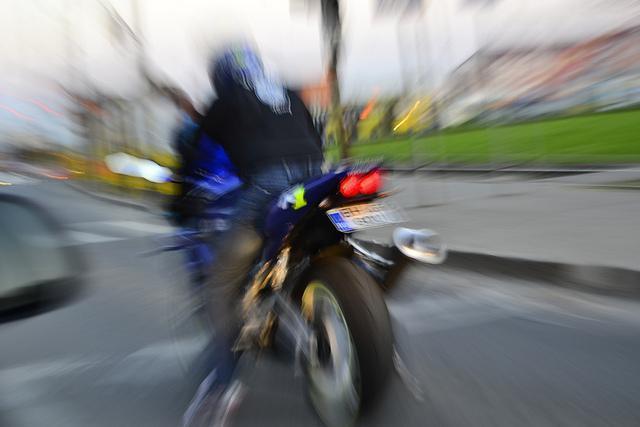How many people are there?
Give a very brief answer. 1. 